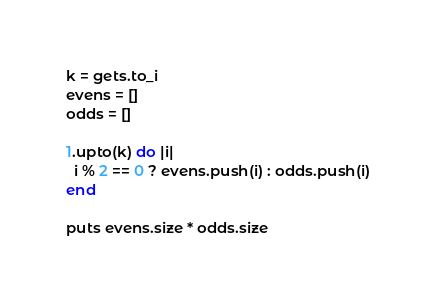Convert code to text. <code><loc_0><loc_0><loc_500><loc_500><_Ruby_>k = gets.to_i
evens = []
odds = []

1.upto(k) do |i|
  i % 2 == 0 ? evens.push(i) : odds.push(i)
end

puts evens.size * odds.size</code> 